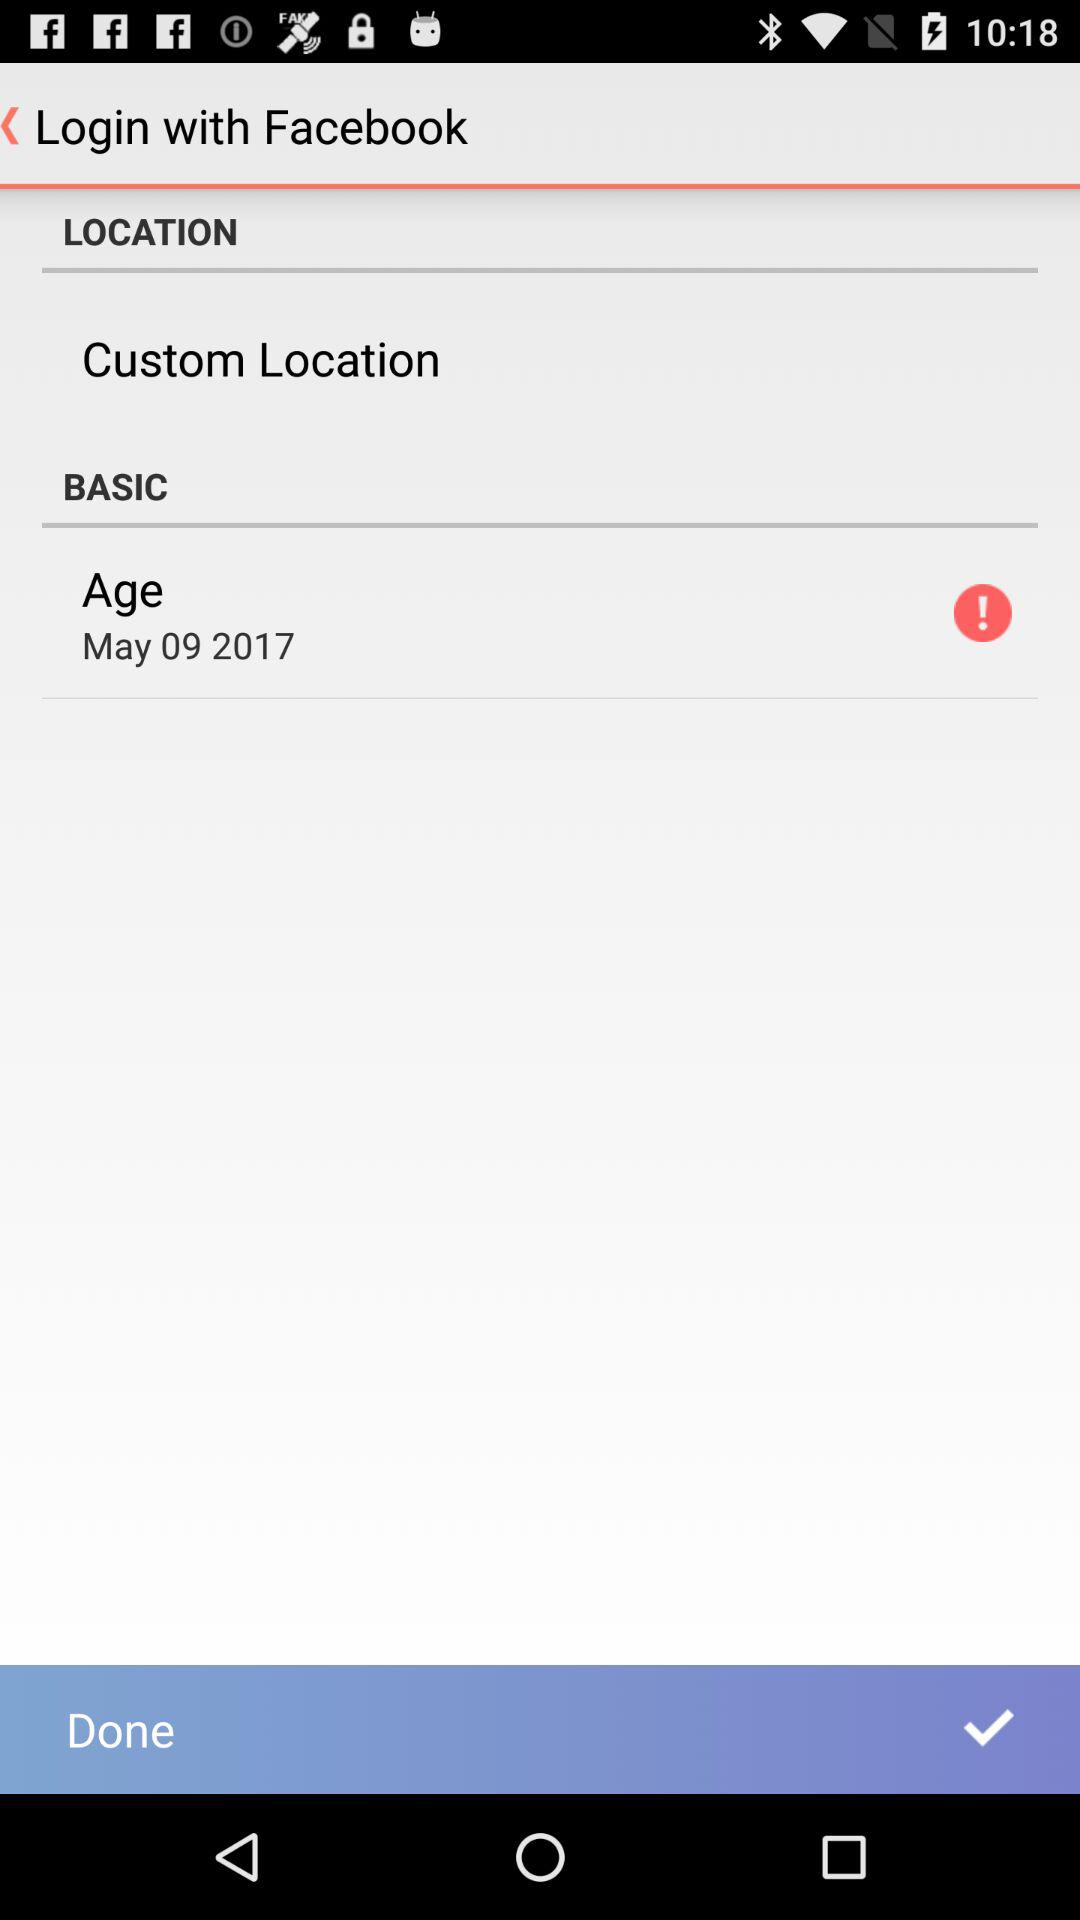Which application is used to log in? The application used to login is "Facebook". 